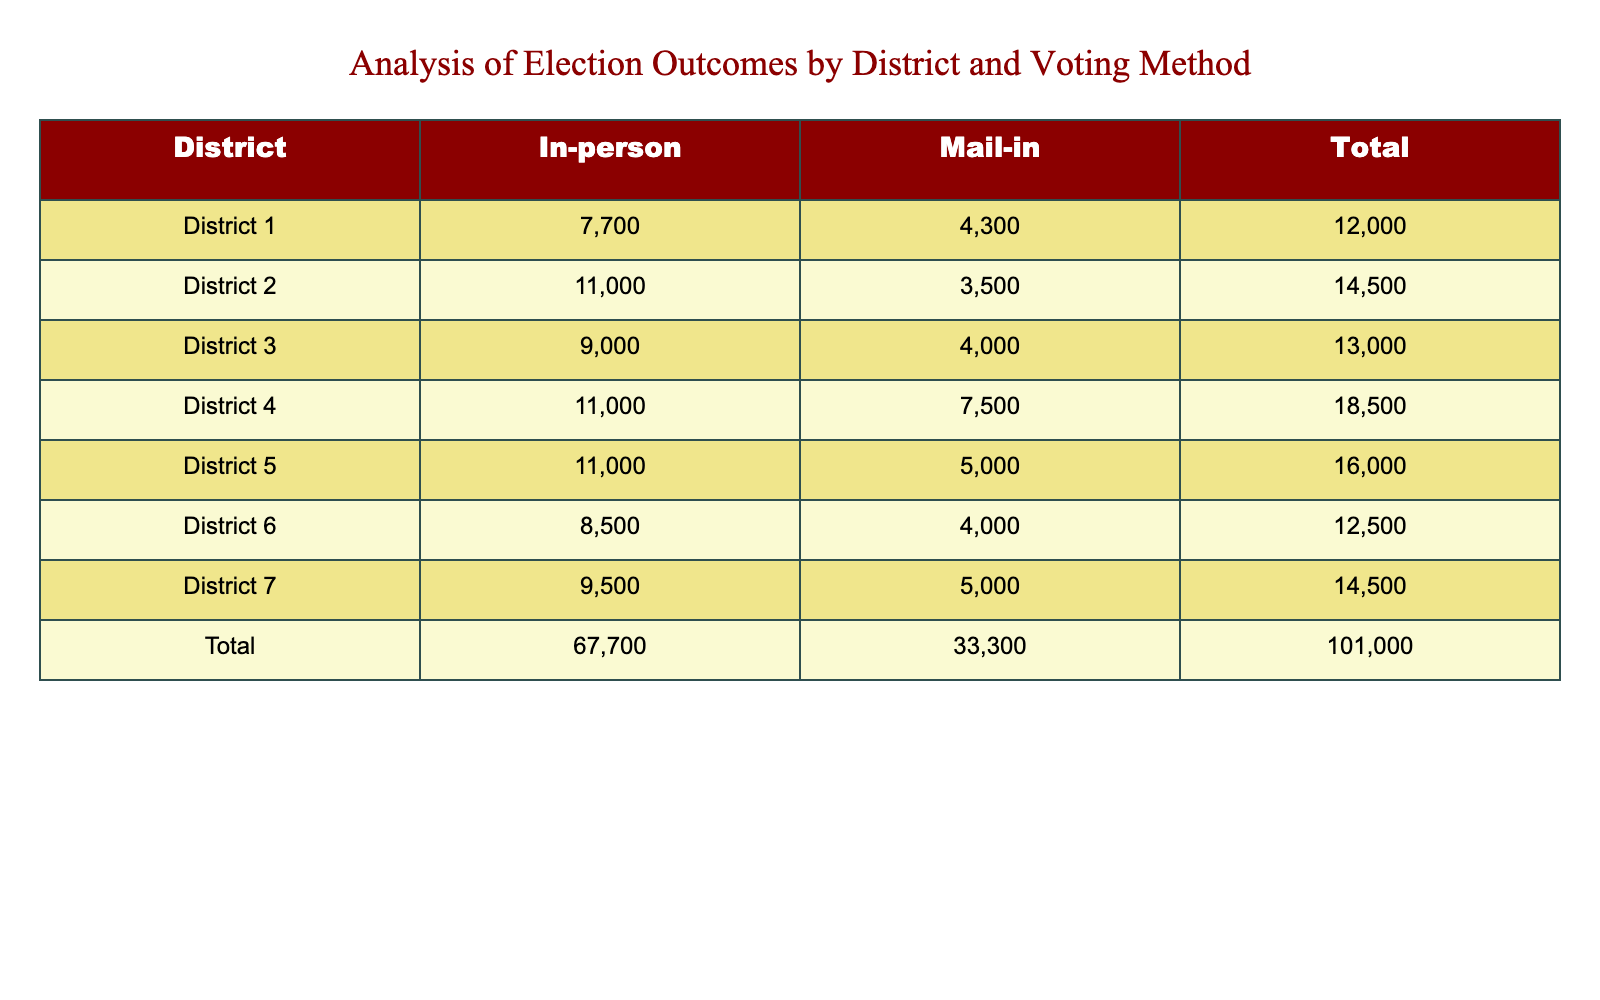What is the total number of votes cast in District 4 for mail-in voting? In District 4, the mail-in voting total is listed as 7500 in the table.
Answer: 7500 How many more Democratic votes were cast in District 3 compared to District 6 for in-person voting? In District 3, the in-person Democratic votes are 7000, and in District 6, they are 4000. The difference is 7000 - 4000 = 3000.
Answer: 3000 Did District 5 have more Republican votes in mail-in voting than in-person voting? In District 5, the in-person Republican votes are 3000 and the mail-in Republican votes are 2100. Since 3000 is greater than 2100, the statement is true.
Answer: Yes What is the total number of votes cast in District 2 across both voting methods? In District 2, the total votes for in-person are 11000 and for mail-in are 3500. Adding these gives 11000 + 3500 = 14500.
Answer: 14500 Which district had the highest total votes for in-person voting, and what was that total? Looking at all districts, District 2 has the highest total in-person votes of 11000.
Answer: District 2, 11000 If you combine the total votes for mail-in voting from District 1 and District 7, what is the result? The mail-in total for District 1 is 4300 and for District 7 is 5000. Combining them gives 4300 + 5000 = 9300.
Answer: 9300 Is the total number of votes in District 6 for in-person voting greater than the total in District 1 for mail-in voting? In District 6, the in-person total is 8500, while in District 1, the mail-in total is 4300. Since 8500 is greater than 4300, the answer is yes.
Answer: Yes How many total Democratic votes were cast in District 4 for both voting methods? The total Democratic votes in District 4 for in-person are 6000 and for mail-in are 3500. Summing these gives 6000 + 3500 = 9500.
Answer: 9500 What is the average number of total votes for all districts in mail-in voting? The totals for mail-in voting by district are 4300 (District 1), 3500 (District 2), 4000 (District 3), 7500 (District 4), 5000 (District 5), 4000 (District 6), and 5000 (District 7), which sums to 28500 across 7 districts. The average is 28500 / 7 = 4071.43, rounded to 4071.
Answer: 4071 